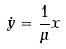<formula> <loc_0><loc_0><loc_500><loc_500>\dot { y } = \frac { 1 } { \mu } x</formula> 